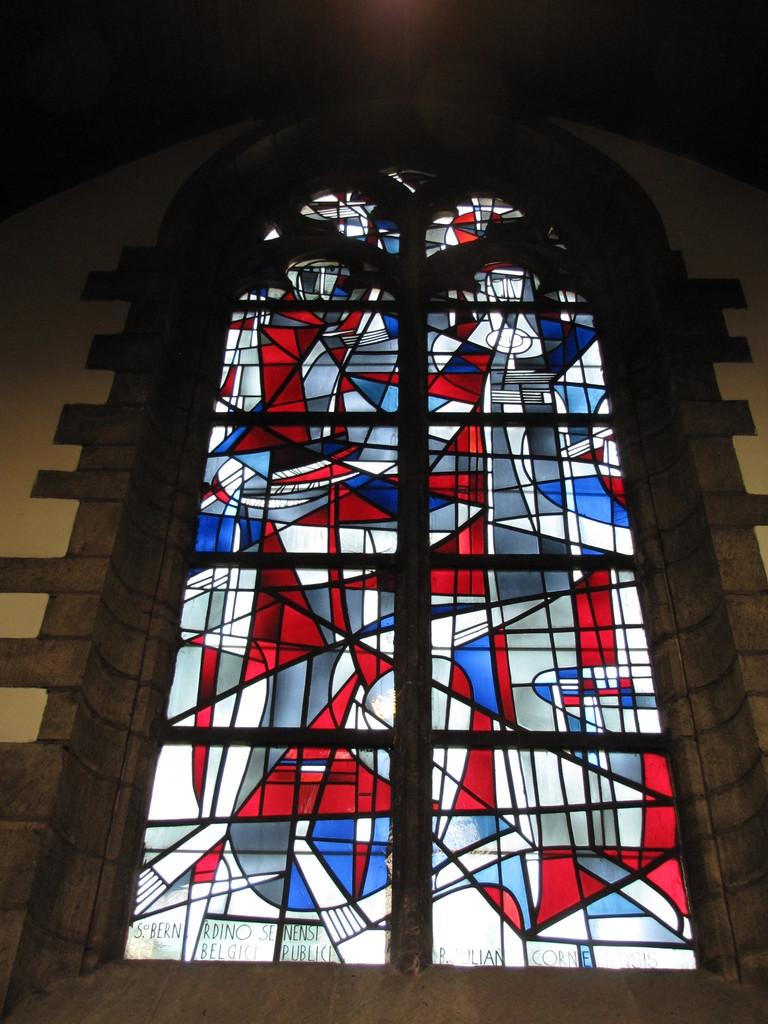What type of window is visible in the image? There is a glass window in the image. What colors can be seen on the glass window? The glass window has a red and blue color pattern. What type of button is being taught by the crow in the image? There is no crow or button present in the image. 